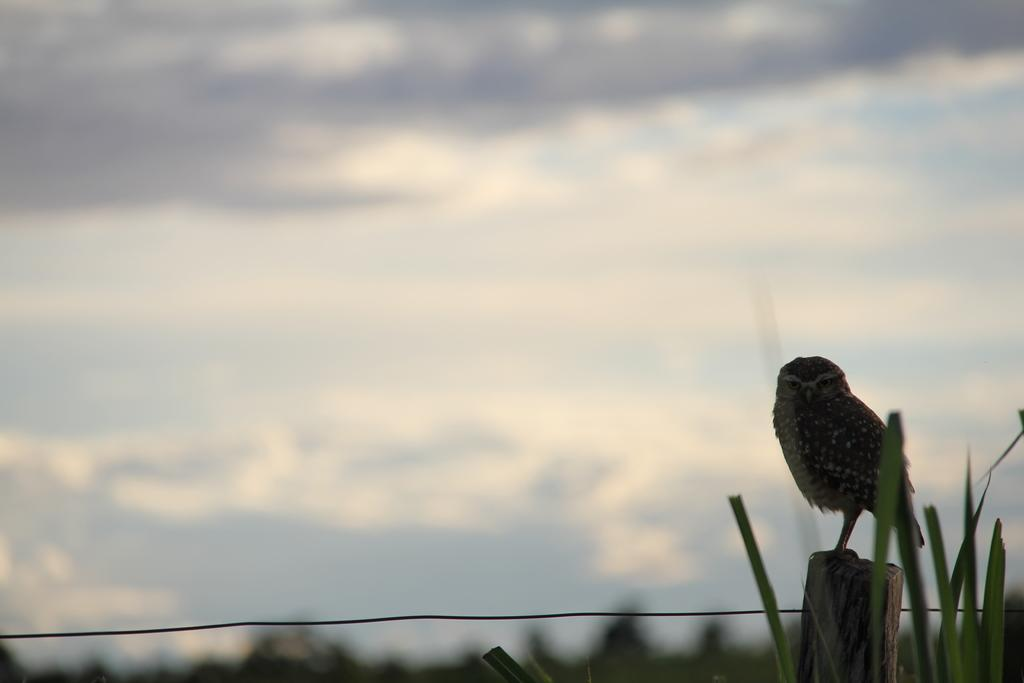What type of animal can be seen in the image? There is a bird in the image. What is the bird doing in the image? The bird is standing on an object. Can you describe any other elements in the image? There is a wire in the image. How would you describe the background of the image? The background of the image is blurred. What historical event is being commemorated by the bird in the image? There is no indication of a historical event or commemoration in the image; it simply features a bird standing on an object. 